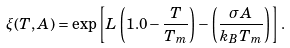<formula> <loc_0><loc_0><loc_500><loc_500>\xi ( T , A ) = \exp \left [ L \left ( 1 . 0 - \frac { T } { T _ { m } } \right ) - \left ( \frac { \sigma A } { k _ { B } T _ { m } } \right ) \right ] .</formula> 